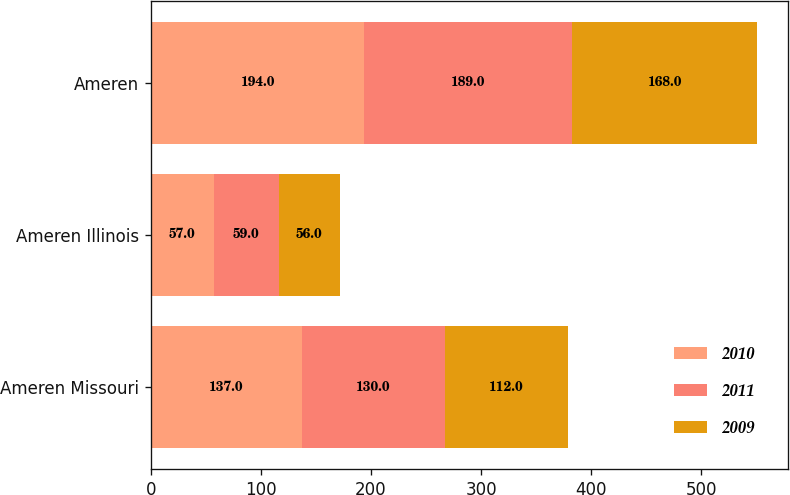<chart> <loc_0><loc_0><loc_500><loc_500><stacked_bar_chart><ecel><fcel>Ameren Missouri<fcel>Ameren Illinois<fcel>Ameren<nl><fcel>2010<fcel>137<fcel>57<fcel>194<nl><fcel>2011<fcel>130<fcel>59<fcel>189<nl><fcel>2009<fcel>112<fcel>56<fcel>168<nl></chart> 